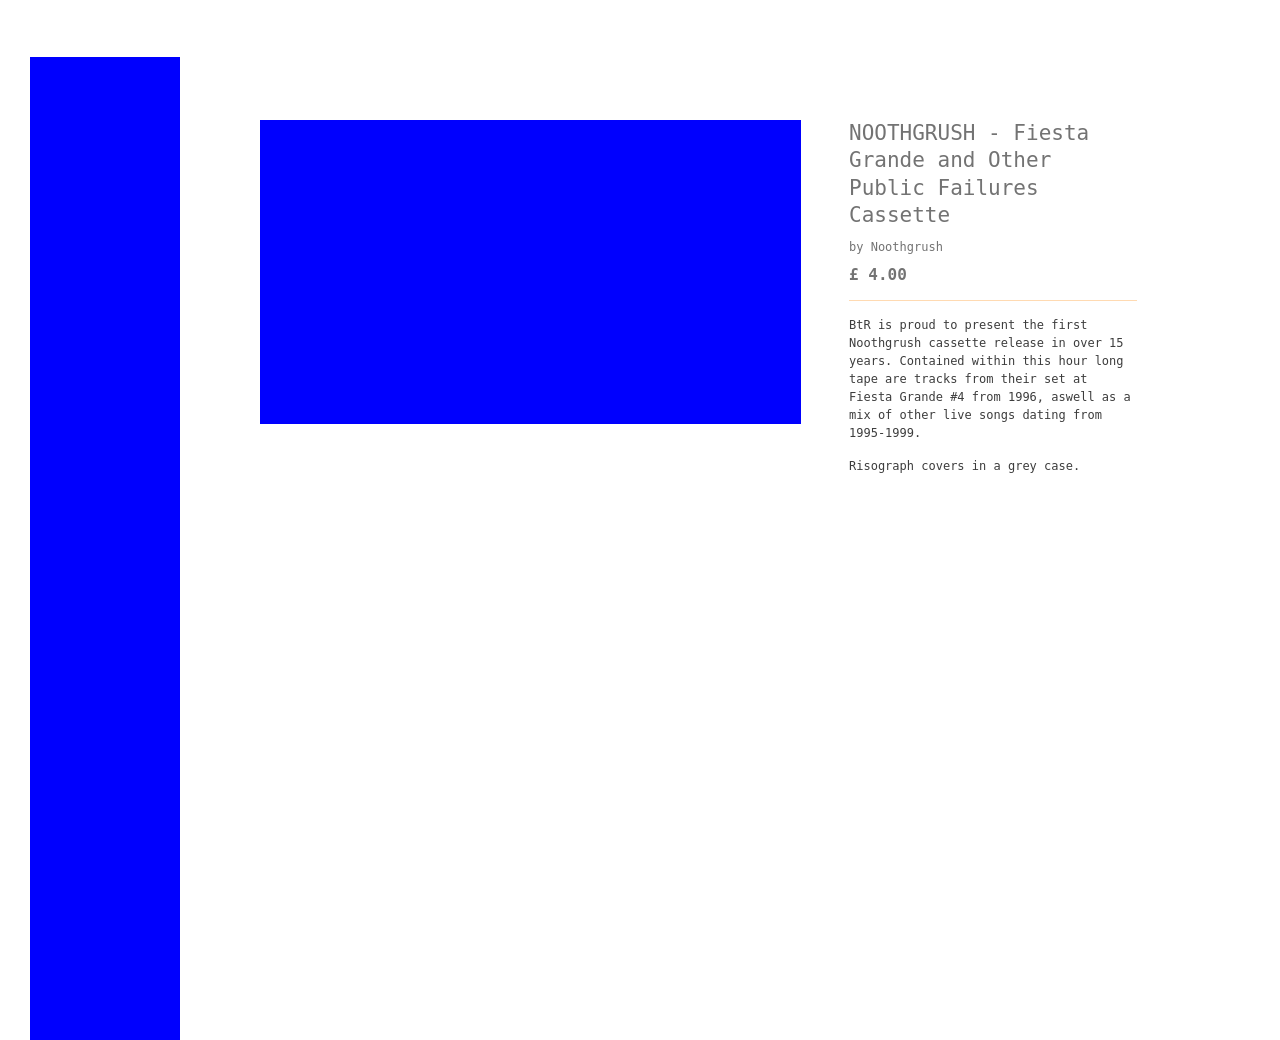Can you describe what's depicted in this image related to the Fiesta Grande and Noothgrush cassette? The image shows a graphic design related to the 'NOOTHGRUSH - Fiesta Grande and Other Public Failures Cassette'. It includes the cassette pricing at £4.00 and a description mentioning it harbors recordings from their live set at Fiesta Grande #4 from 1996, among other live performances from 1995-1999. 
Are there any specific design elements used in this artwork? The design uses simple geometric shapes and a minimalistic color palette, primarily consisting of blue and white. The text is clear and straightforward, intended to provide essential information concisely. The design could be said to have a utilitarian approach, focusing more on the content and the historical aspect of the music rather than intricate graphical elements. 